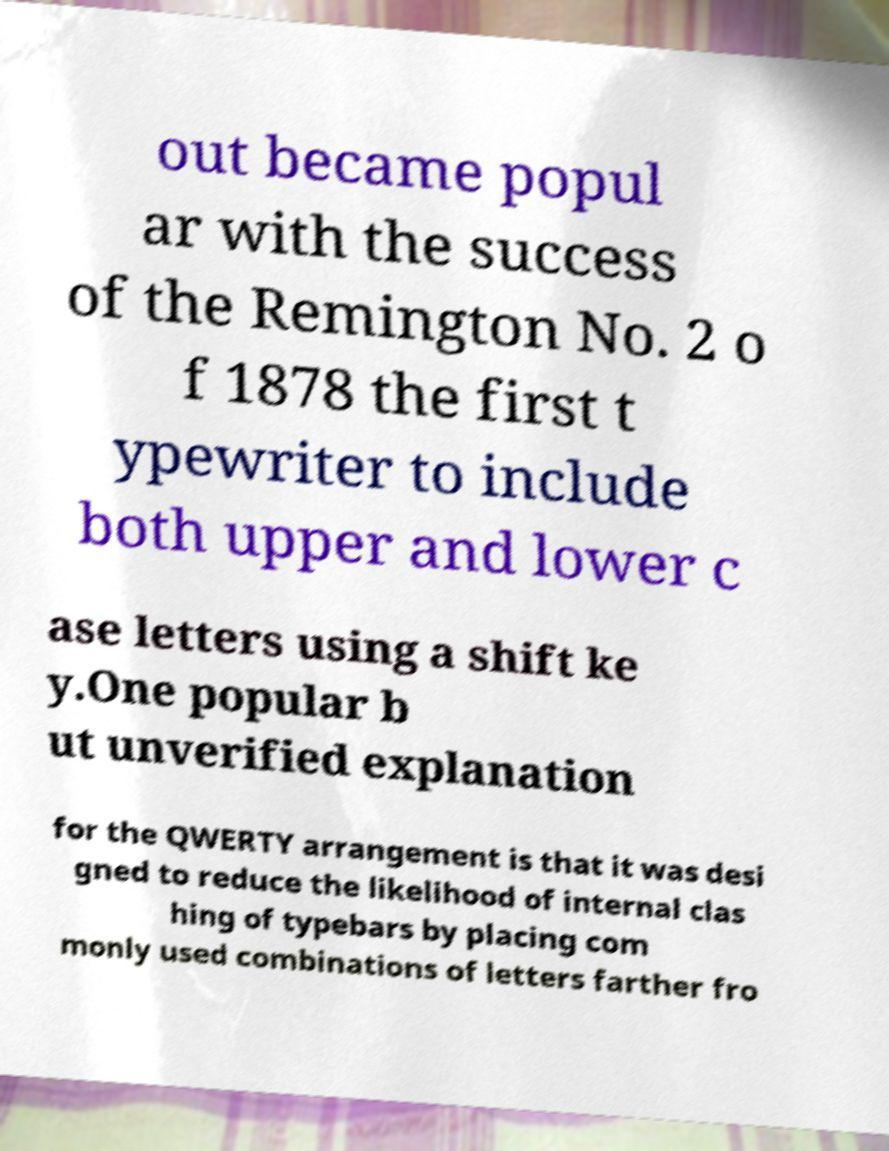Can you accurately transcribe the text from the provided image for me? out became popul ar with the success of the Remington No. 2 o f 1878 the first t ypewriter to include both upper and lower c ase letters using a shift ke y.One popular b ut unverified explanation for the QWERTY arrangement is that it was desi gned to reduce the likelihood of internal clas hing of typebars by placing com monly used combinations of letters farther fro 